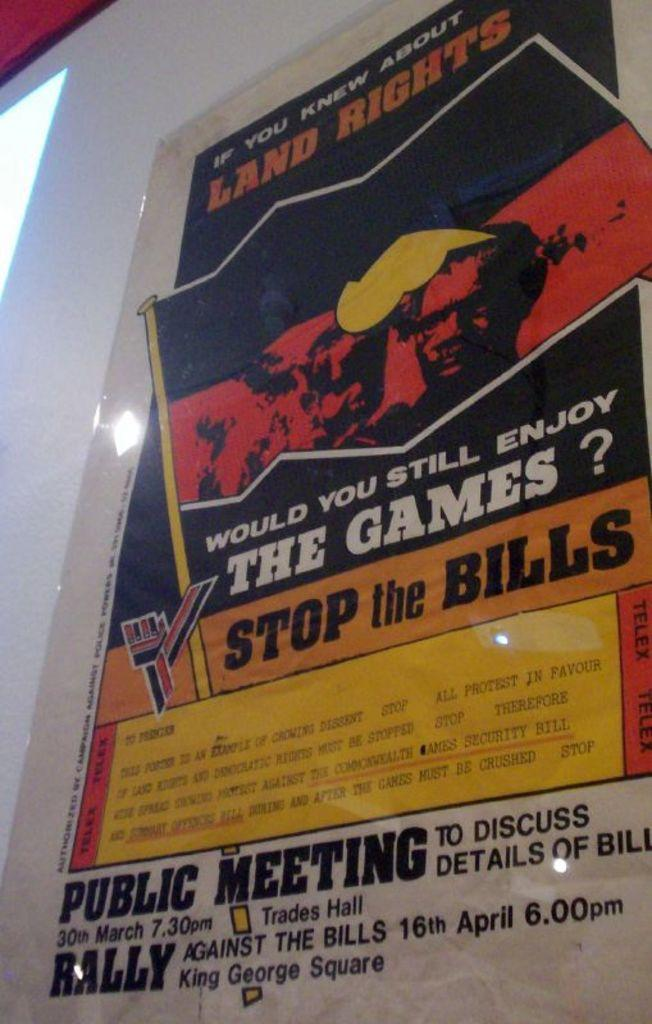What is the main subject of the image? There is an advertisement in the image. Where is the advertisement located? The advertisement is pasted on a wall. What type of farm animals can be seen in the image? There are no farm animals present in the image; it only features an advertisement on a wall. How many feet are visible in the image? There are no feet visible in the image; it only features an advertisement on a wall. 